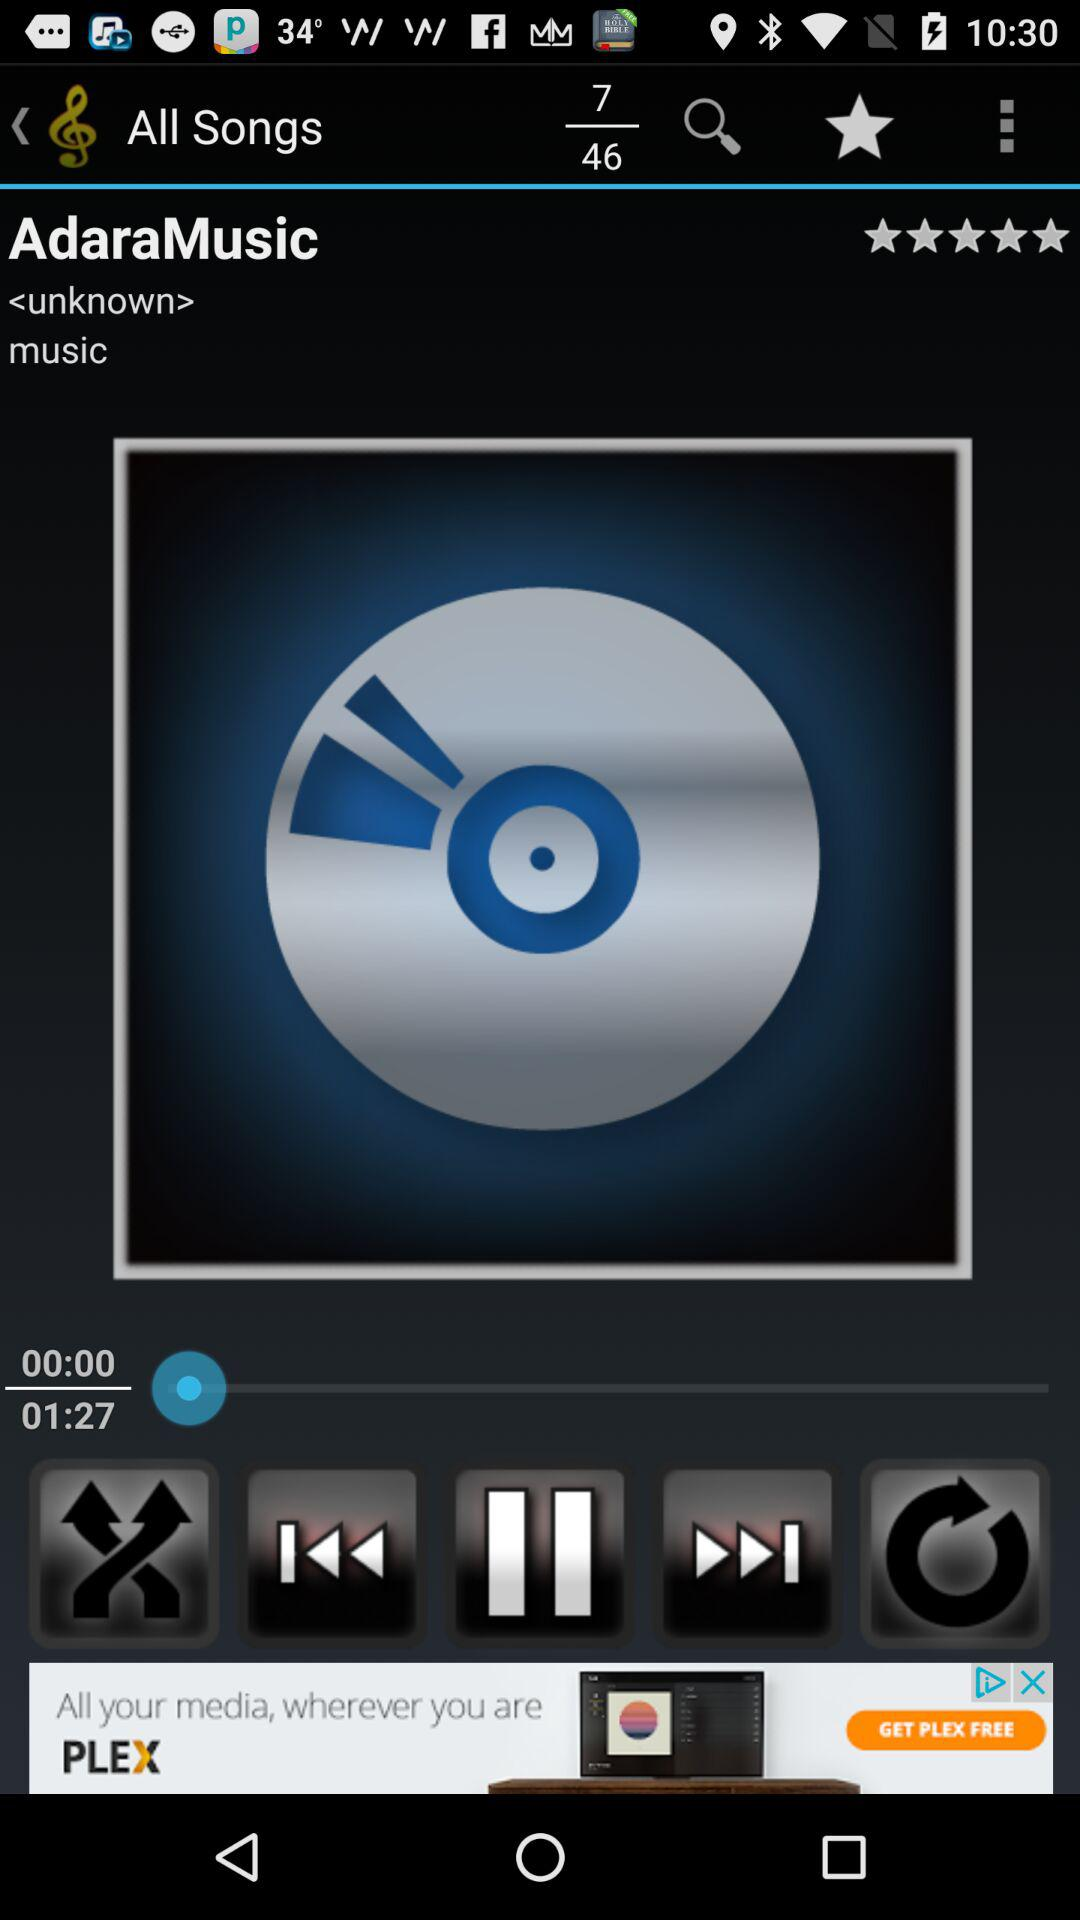What is the total number of songs? The total number of songs is 46. 